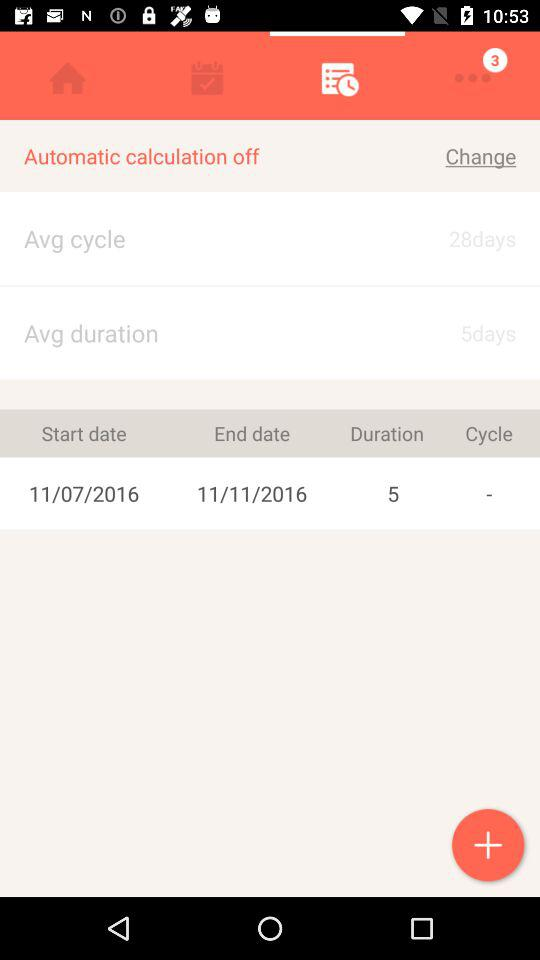What is the end date? The end date is November 11, 2016. 